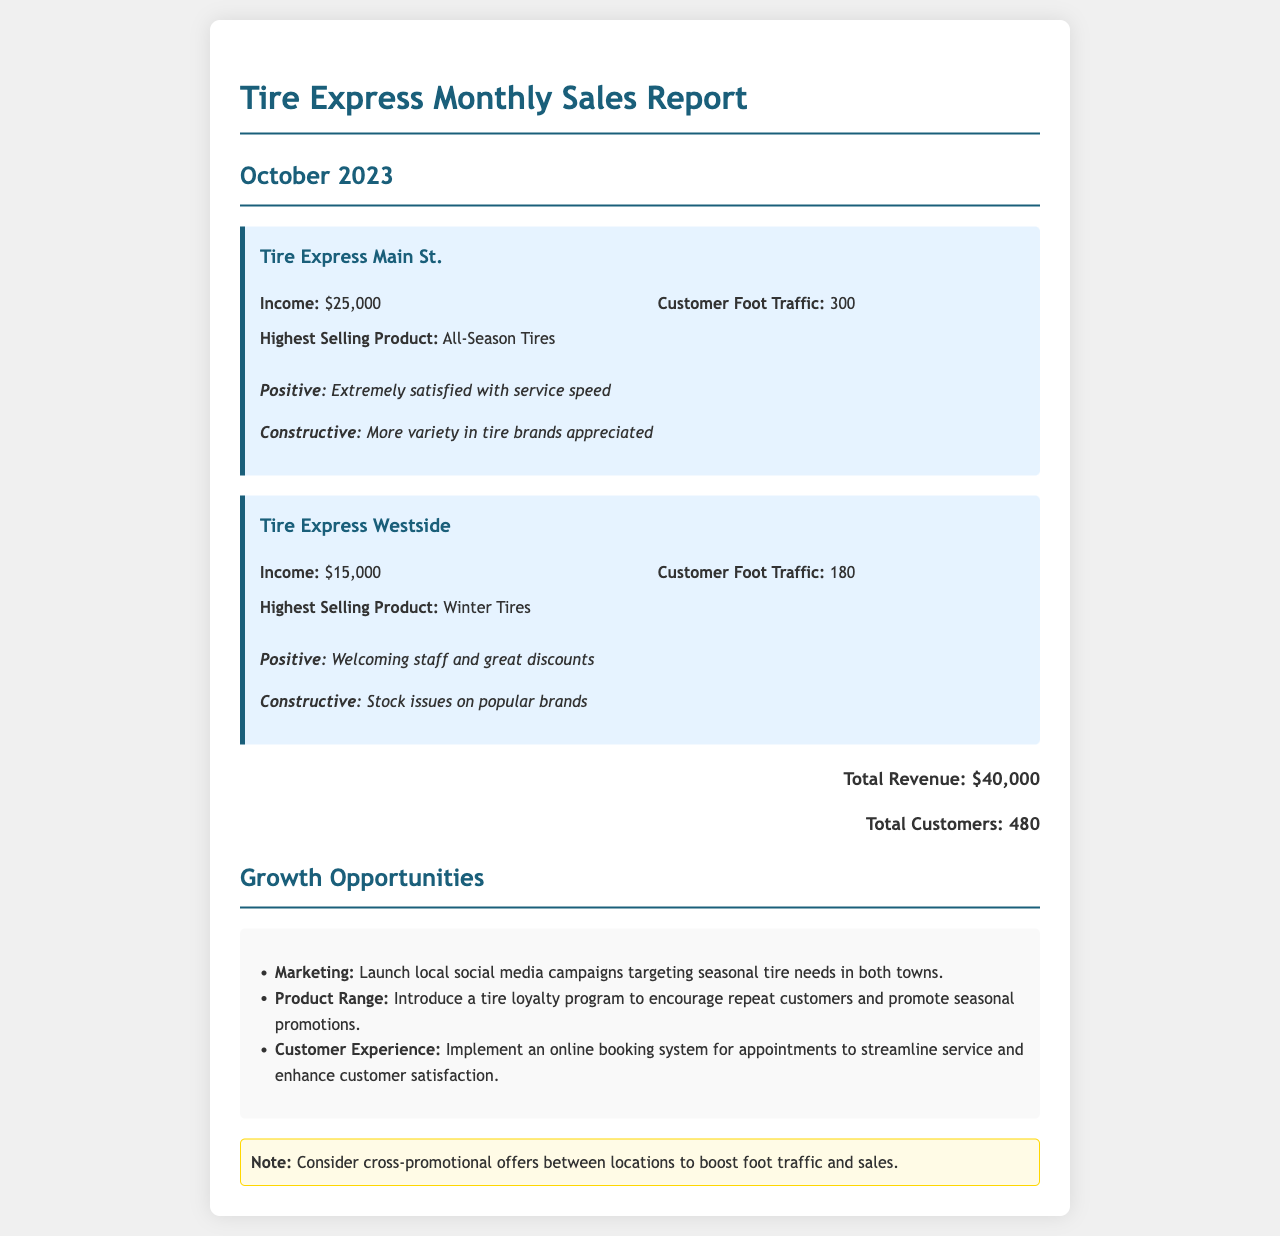What is the income for Tire Express Main St.? The income for Tire Express Main St. is explicitly stated in the document as $25,000.
Answer: $25,000 What is the customer foot traffic for Tire Express Westside? The customer foot traffic for Tire Express Westside is listed as 180 in the report.
Answer: 180 What is the highest selling product at Tire Express Main St.? The report specifies that the highest selling product at Tire Express Main St. is All-Season Tires.
Answer: All-Season Tires What is the total number of customers served at both locations? The total number of customers can be found by adding the foot traffic of both locations, resulting in 300 + 180 = 480.
Answer: 480 What feedback was given regarding Tire Express Westside's service? The document mentions the positive feedback regarding Tire Express Westside's service as "Welcoming staff and great discounts."
Answer: Welcoming staff and great discounts What marketing opportunity is suggested in the report? The document suggests launching local social media campaigns targeting seasonal tire needs in both towns as a marketing opportunity.
Answer: Local social media campaigns What is the reported income for Tire Express Westside? The income for Tire Express Westside is stated clearly in the document as $15,000.
Answer: $15,000 What type of program is suggested to encourage repeat customers? A tire loyalty program is suggested to encourage repeat customers in the growth opportunities section.
Answer: Tire loyalty program What is the total revenue for both locations combined? The total revenue is presented as the sum of the incomes from both locations: $25,000 + $15,000 = $40,000.
Answer: $40,000 